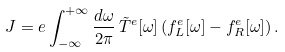<formula> <loc_0><loc_0><loc_500><loc_500>J = e \int _ { - \infty } ^ { + \infty } \frac { d \omega } { 2 \pi } \, \tilde { T } ^ { e } [ \omega ] \left ( f ^ { e } _ { L } [ \omega ] - f ^ { e } _ { R } [ \omega ] \right ) .</formula> 